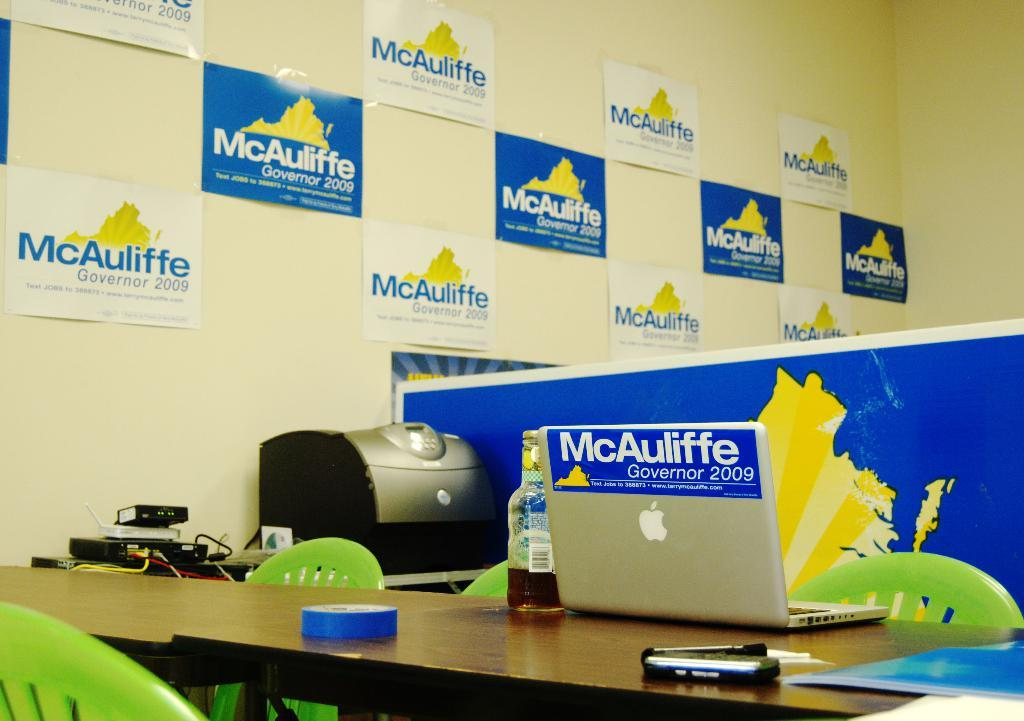<image>
Share a concise interpretation of the image provided. An office is filled with different McAuliffe signs. 